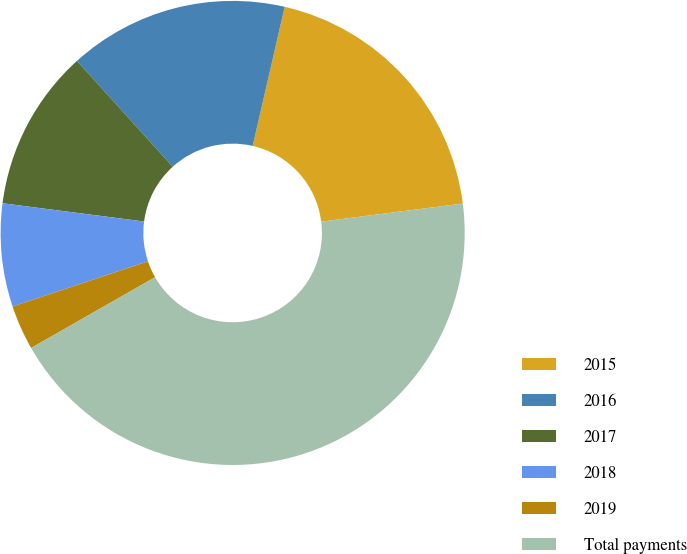<chart> <loc_0><loc_0><loc_500><loc_500><pie_chart><fcel>2015<fcel>2016<fcel>2017<fcel>2018<fcel>2019<fcel>Total payments<nl><fcel>19.38%<fcel>15.31%<fcel>11.25%<fcel>7.18%<fcel>3.12%<fcel>43.77%<nl></chart> 